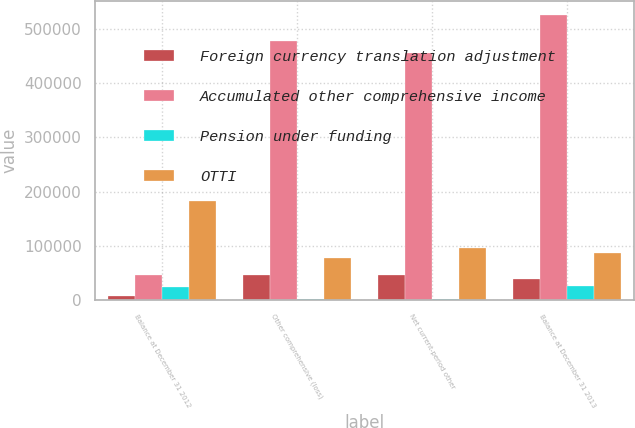Convert chart to OTSL. <chart><loc_0><loc_0><loc_500><loc_500><stacked_bar_chart><ecel><fcel>Balance at December 31 2012<fcel>Other comprehensive (loss)<fcel>Net current-period other<fcel>Balance at December 31 2013<nl><fcel>Foreign currency translation adjustment<fcel>6882<fcel>45649<fcel>45649<fcel>38767<nl><fcel>Accumulated other comprehensive income<fcel>45649<fcel>478853<fcel>455808<fcel>526071<nl><fcel>Pension under funding<fcel>23861<fcel>2237<fcel>2566<fcel>26427<nl><fcel>OTTI<fcel>182219<fcel>77938<fcel>95318<fcel>86901<nl></chart> 